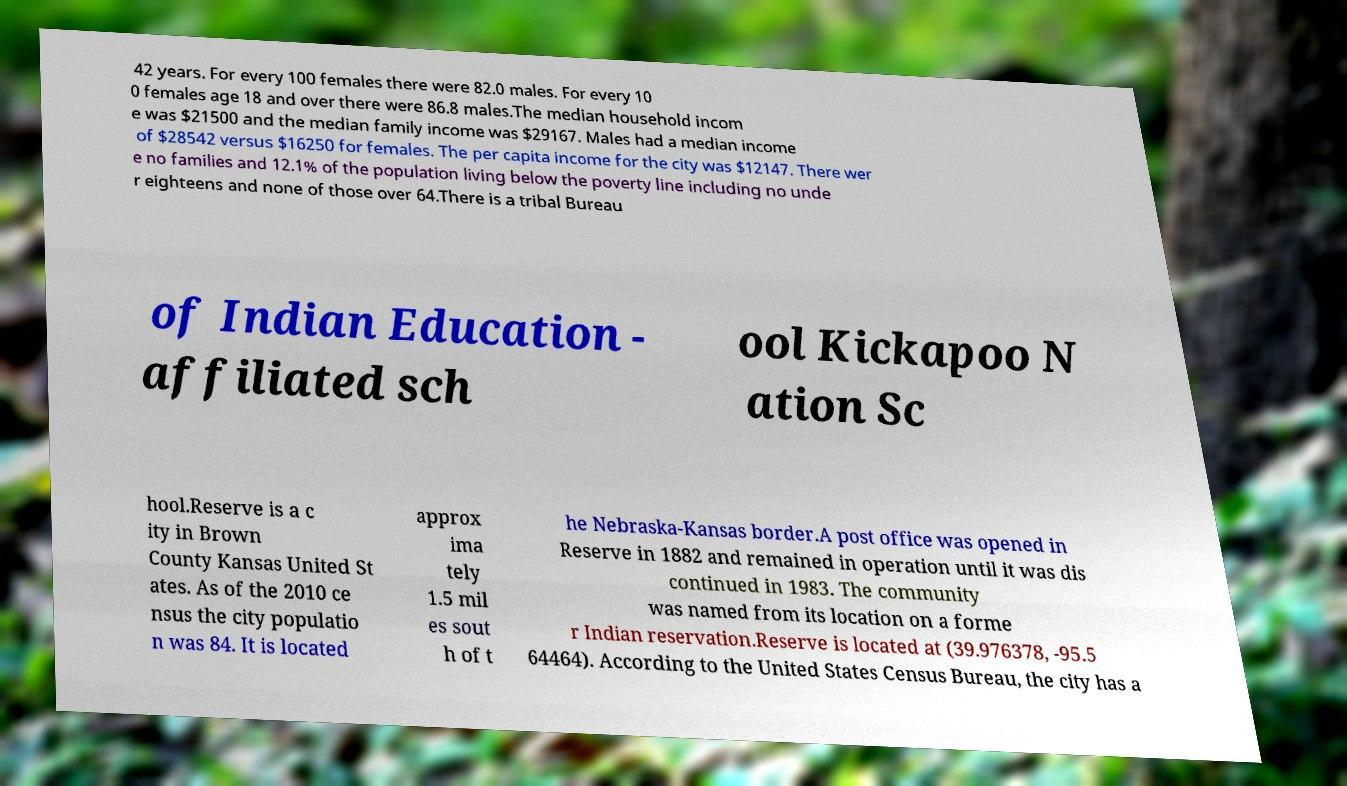I need the written content from this picture converted into text. Can you do that? 42 years. For every 100 females there were 82.0 males. For every 10 0 females age 18 and over there were 86.8 males.The median household incom e was $21500 and the median family income was $29167. Males had a median income of $28542 versus $16250 for females. The per capita income for the city was $12147. There wer e no families and 12.1% of the population living below the poverty line including no unde r eighteens and none of those over 64.There is a tribal Bureau of Indian Education - affiliated sch ool Kickapoo N ation Sc hool.Reserve is a c ity in Brown County Kansas United St ates. As of the 2010 ce nsus the city populatio n was 84. It is located approx ima tely 1.5 mil es sout h of t he Nebraska-Kansas border.A post office was opened in Reserve in 1882 and remained in operation until it was dis continued in 1983. The community was named from its location on a forme r Indian reservation.Reserve is located at (39.976378, -95.5 64464). According to the United States Census Bureau, the city has a 